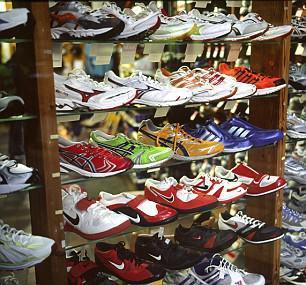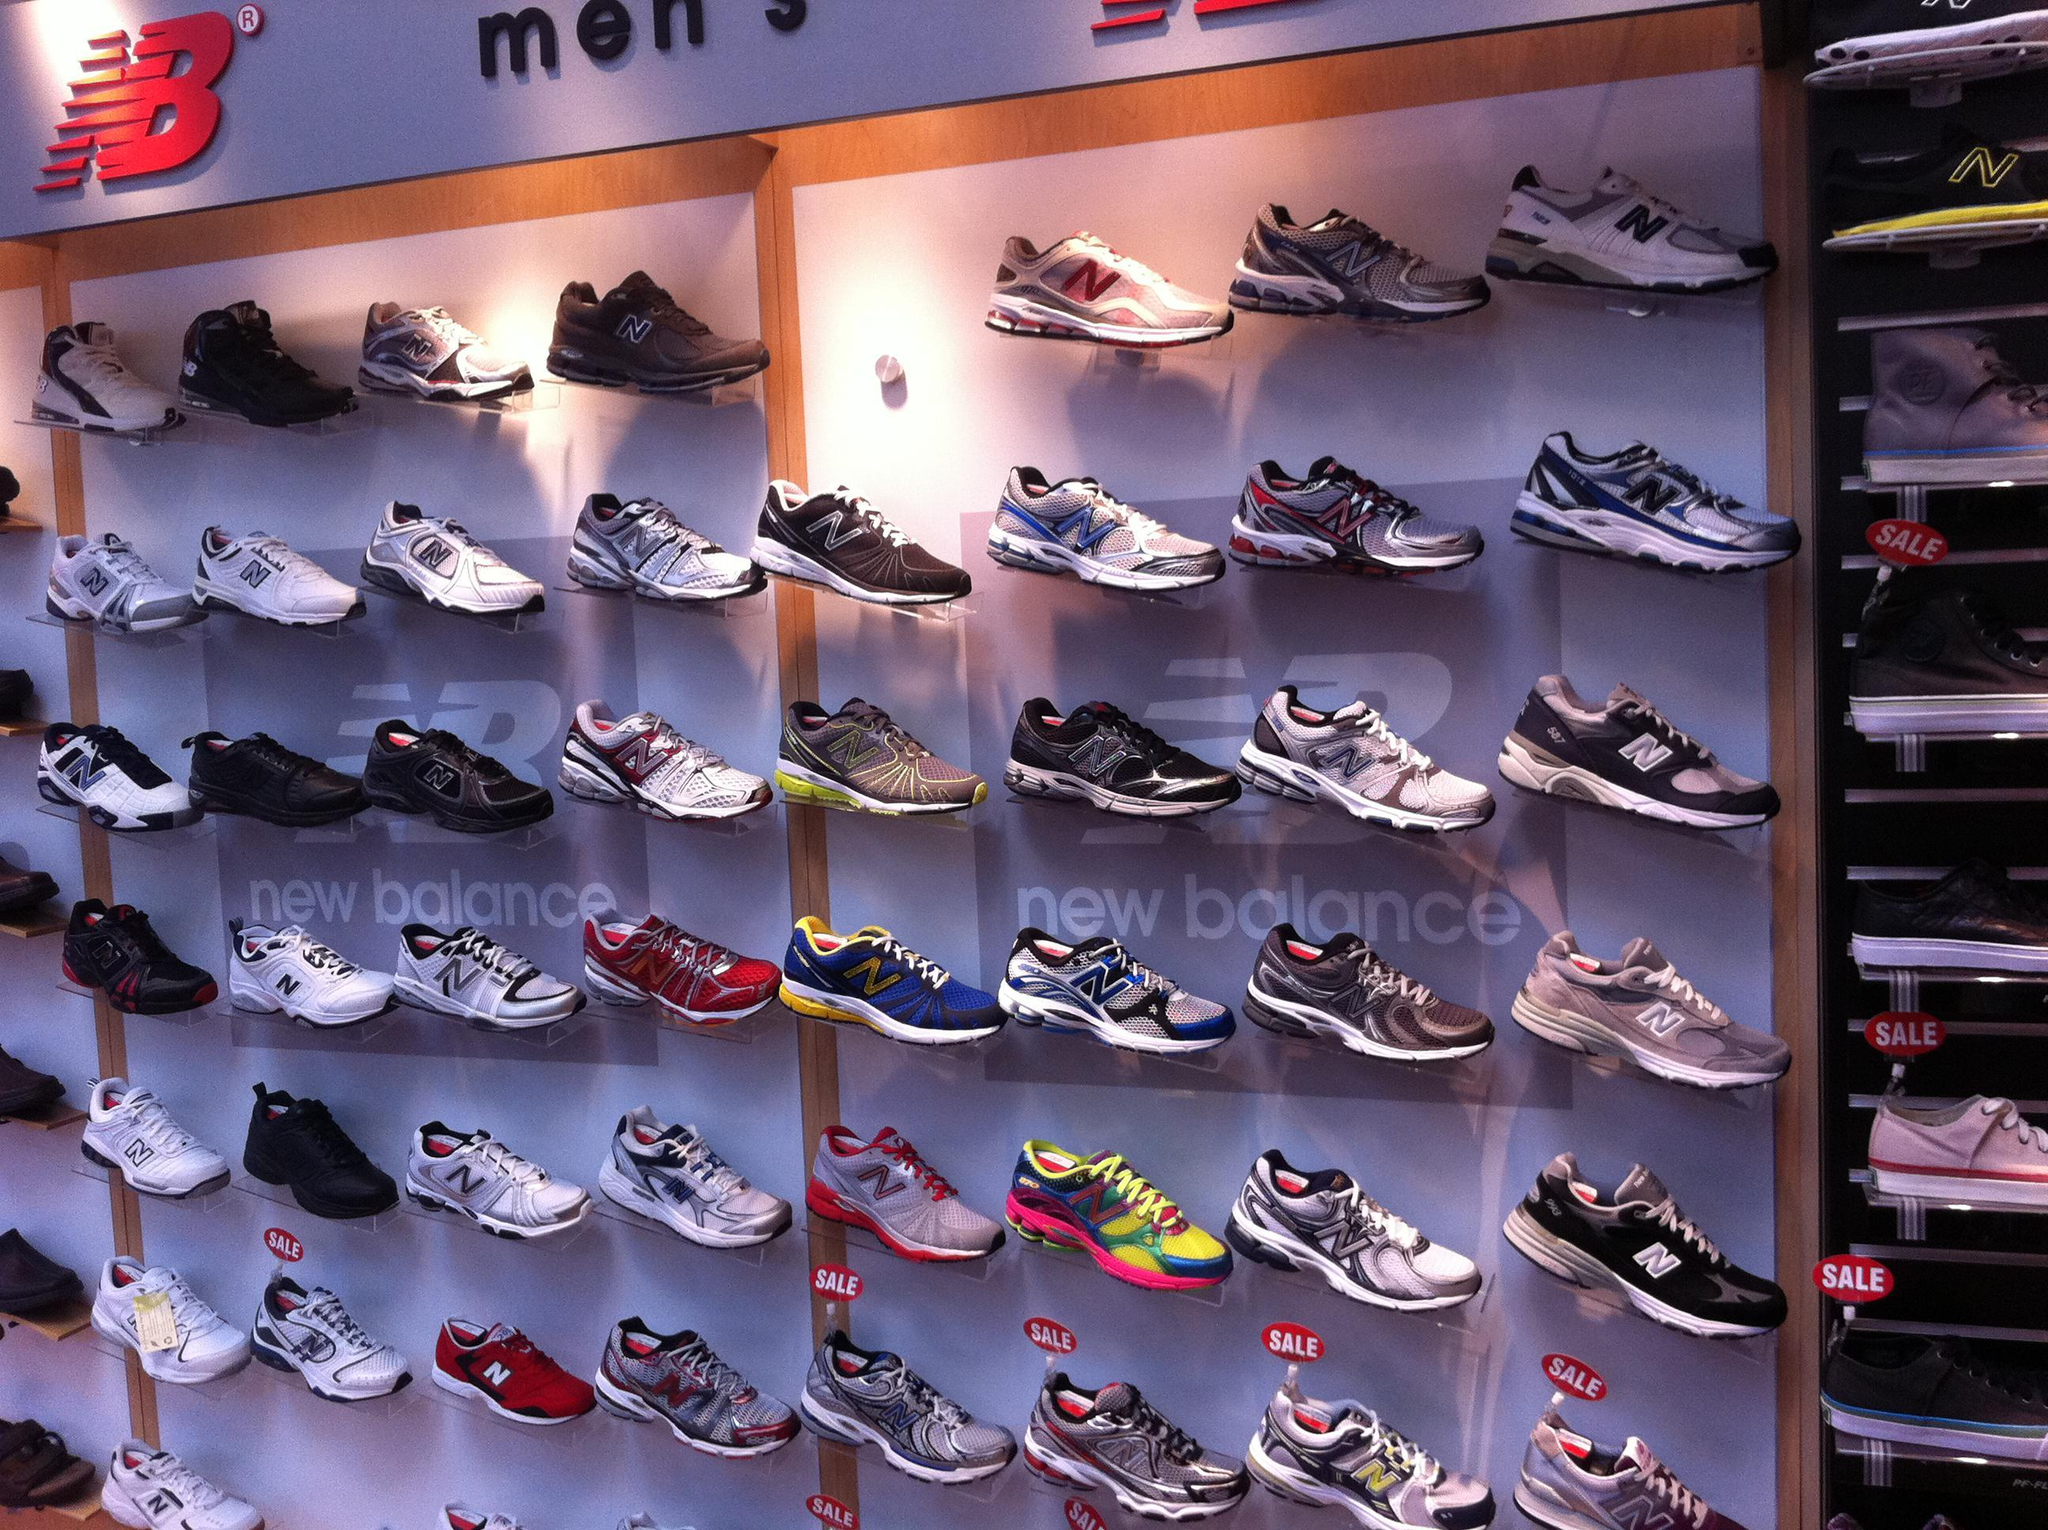The first image is the image on the left, the second image is the image on the right. Evaluate the accuracy of this statement regarding the images: "The shoes are displayed horizontally on the wall in the image on the right.". Is it true? Answer yes or no. Yes. 